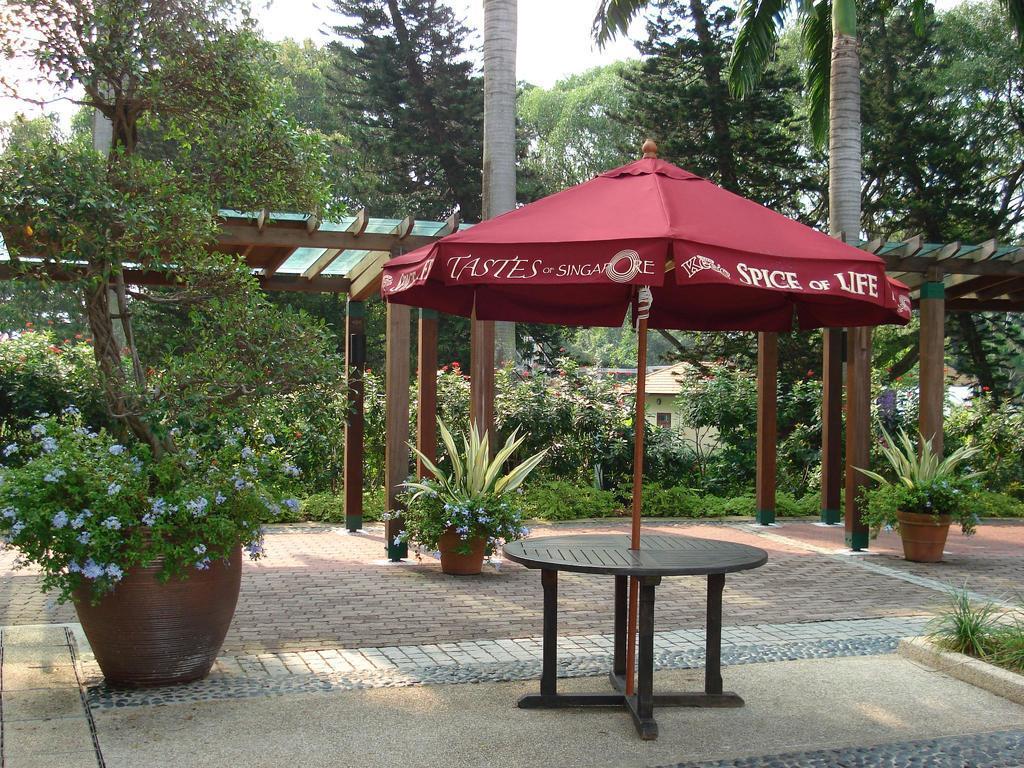Could you give a brief overview of what you see in this image? In this image I see a table, few plants in the pots and I see lot of trees. 